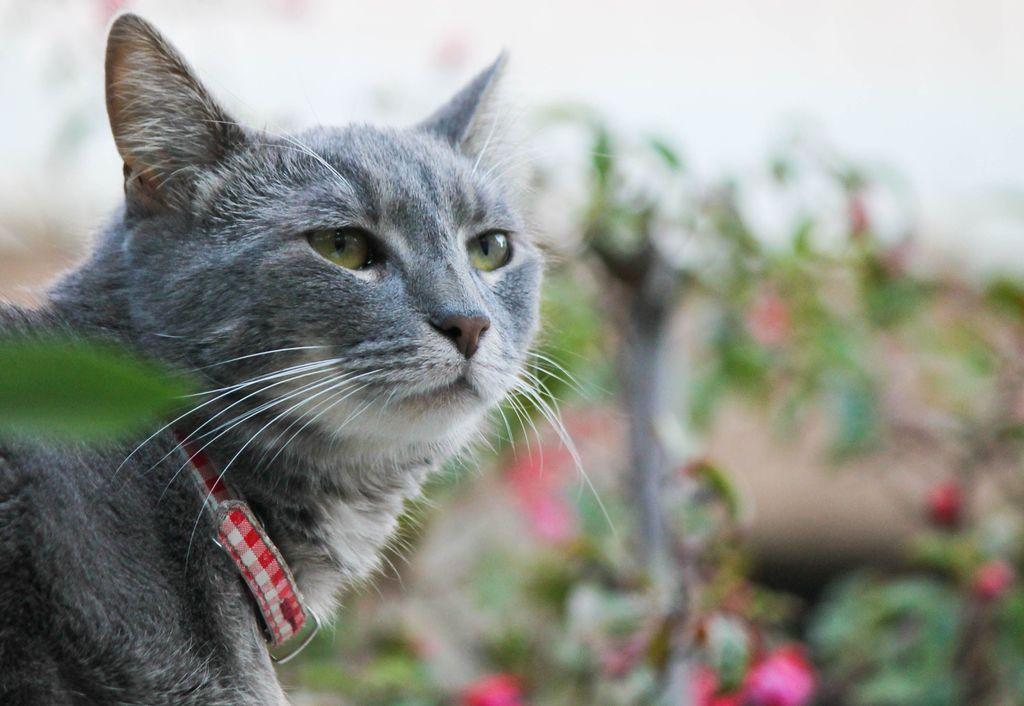What type of living organisms can be seen in the image? There are flowers and plants in the image. What animal is present in the image? There is a cat in the image. What disease is the cat suffering from in the image? There is no indication in the image that the cat is suffering from any disease. 